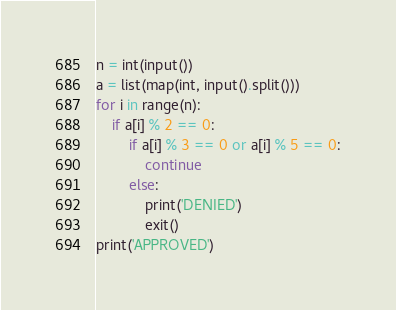<code> <loc_0><loc_0><loc_500><loc_500><_Python_>n = int(input())
a = list(map(int, input().split()))
for i in range(n):
    if a[i] % 2 == 0:
        if a[i] % 3 == 0 or a[i] % 5 == 0:
            continue
        else:
            print('DENIED')
            exit()
print('APPROVED')
</code> 